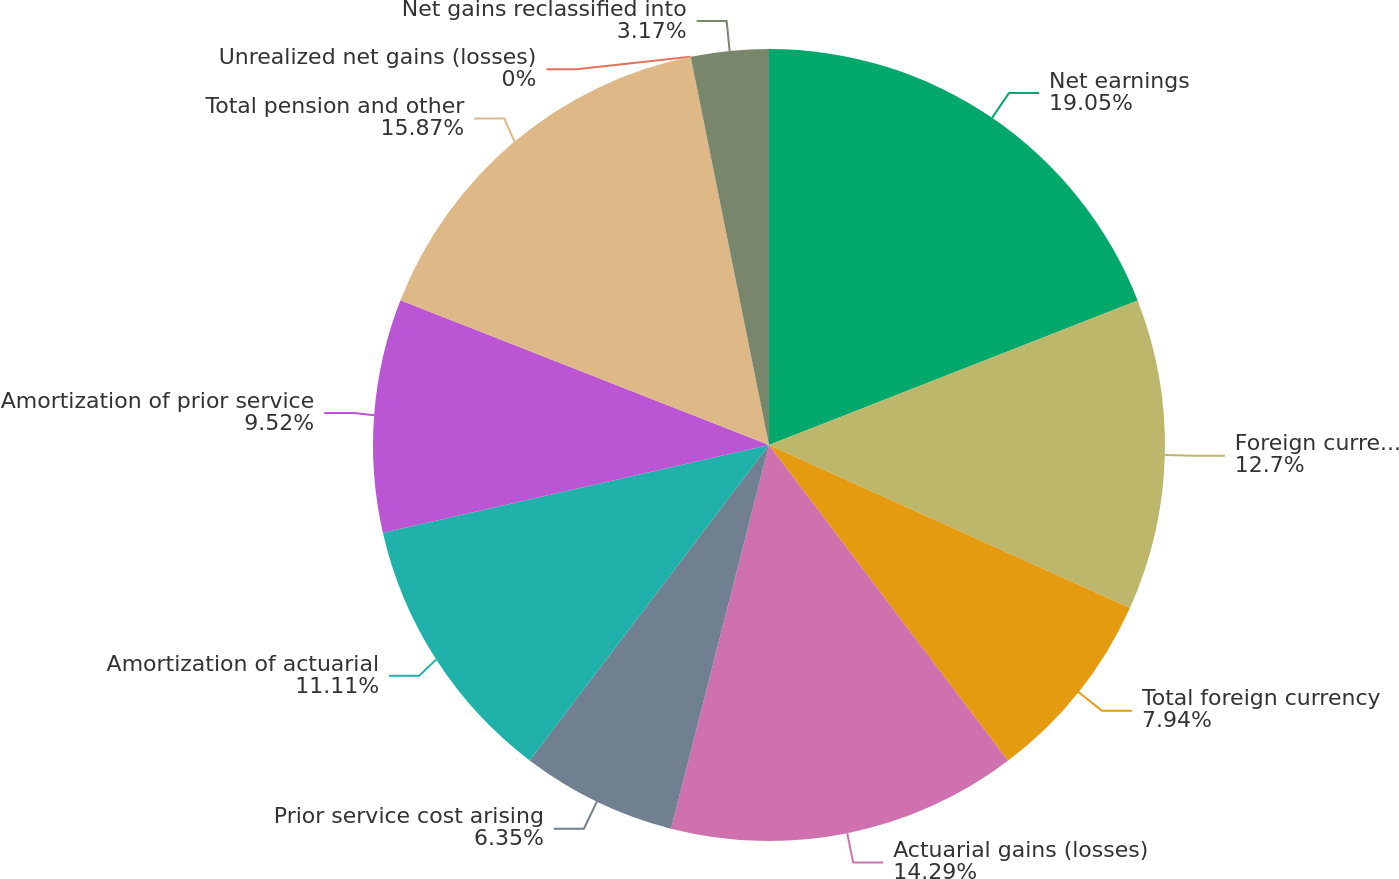Convert chart. <chart><loc_0><loc_0><loc_500><loc_500><pie_chart><fcel>Net earnings<fcel>Foreign currency translation<fcel>Total foreign currency<fcel>Actuarial gains (losses)<fcel>Prior service cost arising<fcel>Amortization of actuarial<fcel>Amortization of prior service<fcel>Total pension and other<fcel>Unrealized net gains (losses)<fcel>Net gains reclassified into<nl><fcel>19.05%<fcel>12.7%<fcel>7.94%<fcel>14.29%<fcel>6.35%<fcel>11.11%<fcel>9.52%<fcel>15.87%<fcel>0.0%<fcel>3.17%<nl></chart> 